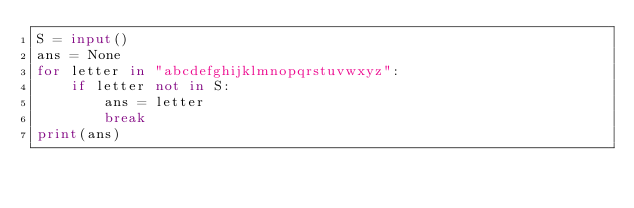<code> <loc_0><loc_0><loc_500><loc_500><_Python_>S = input()
ans = None
for letter in "abcdefghijklmnopqrstuvwxyz":
    if letter not in S:
        ans = letter
        break
print(ans)</code> 